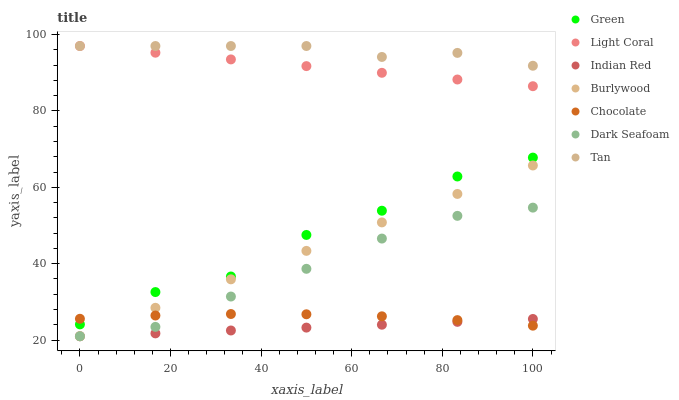Does Indian Red have the minimum area under the curve?
Answer yes or no. Yes. Does Tan have the maximum area under the curve?
Answer yes or no. Yes. Does Chocolate have the minimum area under the curve?
Answer yes or no. No. Does Chocolate have the maximum area under the curve?
Answer yes or no. No. Is Light Coral the smoothest?
Answer yes or no. Yes. Is Green the roughest?
Answer yes or no. Yes. Is Chocolate the smoothest?
Answer yes or no. No. Is Chocolate the roughest?
Answer yes or no. No. Does Burlywood have the lowest value?
Answer yes or no. Yes. Does Chocolate have the lowest value?
Answer yes or no. No. Does Tan have the highest value?
Answer yes or no. Yes. Does Chocolate have the highest value?
Answer yes or no. No. Is Dark Seafoam less than Light Coral?
Answer yes or no. Yes. Is Tan greater than Burlywood?
Answer yes or no. Yes. Does Dark Seafoam intersect Indian Red?
Answer yes or no. Yes. Is Dark Seafoam less than Indian Red?
Answer yes or no. No. Is Dark Seafoam greater than Indian Red?
Answer yes or no. No. Does Dark Seafoam intersect Light Coral?
Answer yes or no. No. 